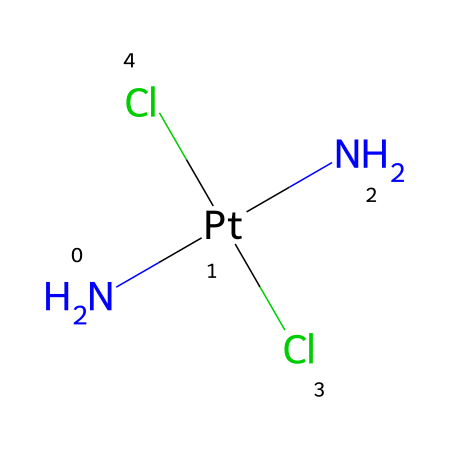What is the central metal atom in the structure? The structure includes a platinum atom at the center of the chemical composition denoted by the ‘Pt’ symbol in the SMILES notation.
Answer: platinum How many nitrogen atoms are present in cisplatin? The SMILES representation shows two nitrogen atoms indicated by the 'N' symbols right before the platinum, showing there are two nitrogen atoms.
Answer: two How many chlorine atoms are present in cisplatin? The chemical structure shows two chlorine atoms represented by the two 'Cl' symbols in the SMILES notation, indicating there are two chlorine atoms.
Answer: two What type of bond connects nitrogen atoms to the platinum? In this structure, the nitrogen atoms are connected to platinum by coordination bonds, which are commonly formed in organometallic compounds where metal centers coordinate directly with ligands.
Answer: coordination bonds Why is cisplatin classified as an organometallic compound? This compound contains a metal atom (platinum) bonded to carbon-based ligands (the nitrogen atoms act as ligands), which is characteristic of organometallic chemistry, where organometallics involve metal-organic bonding.
Answer: organometallic What is the oxidation state of platinum in this structure? In cisplatin, platinum (Pt) is typically in the +2 oxidation state since it is bound with two chloride ions (-1 each) and two neutral nitrogen atoms, resulting in an overall charge balance of zero in the compound.
Answer: +2 